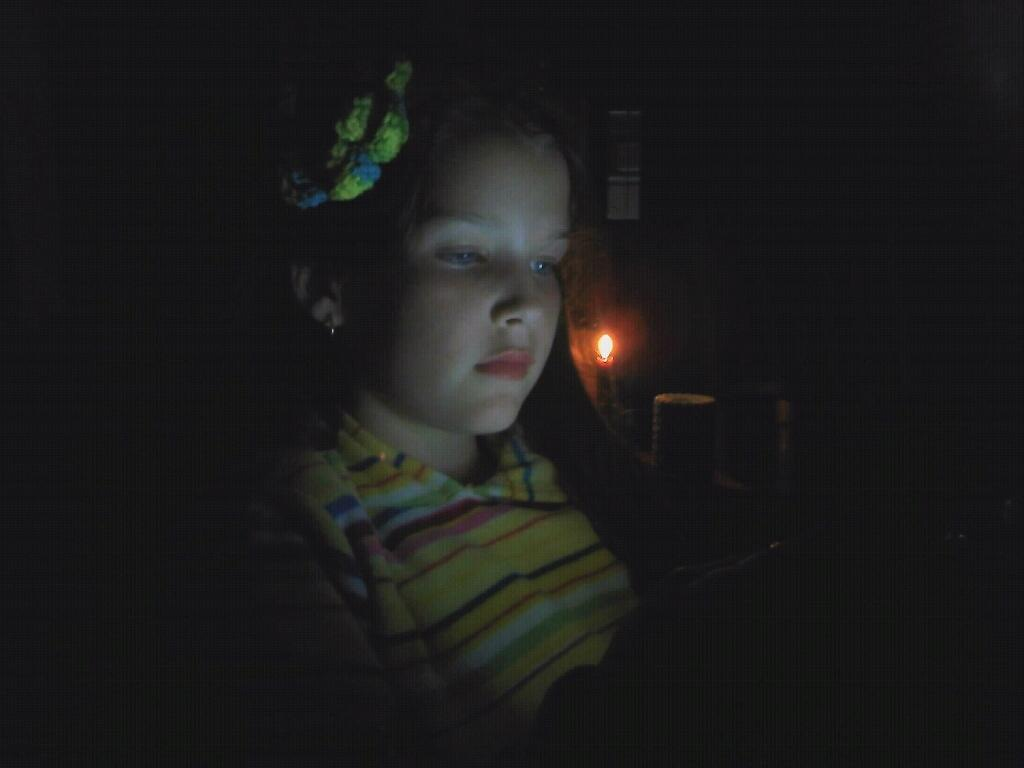Who is present in the image? There is a lady in the image. What is the lady holding in the image? The lady is holding an object. Can you describe the background of the image? The background of the image is ark-like. What other objects can be seen in the image? There is a candle and a cup in the image. What type of bells can be heard during the expert's discussion in the image? There is no mention of bells, an expert, or a discussion in the image. 